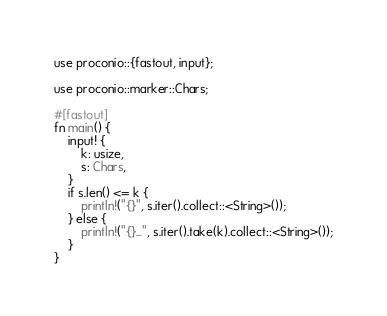<code> <loc_0><loc_0><loc_500><loc_500><_Rust_>use proconio::{fastout, input};

use proconio::marker::Chars;

#[fastout]
fn main() {
    input! {
        k: usize,
        s: Chars,
    }
    if s.len() <= k {
        println!("{}", s.iter().collect::<String>());
    } else {
        println!("{}...", s.iter().take(k).collect::<String>());
    }
}
</code> 